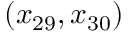<formula> <loc_0><loc_0><loc_500><loc_500>( x _ { 2 9 } , x _ { 3 0 } )</formula> 